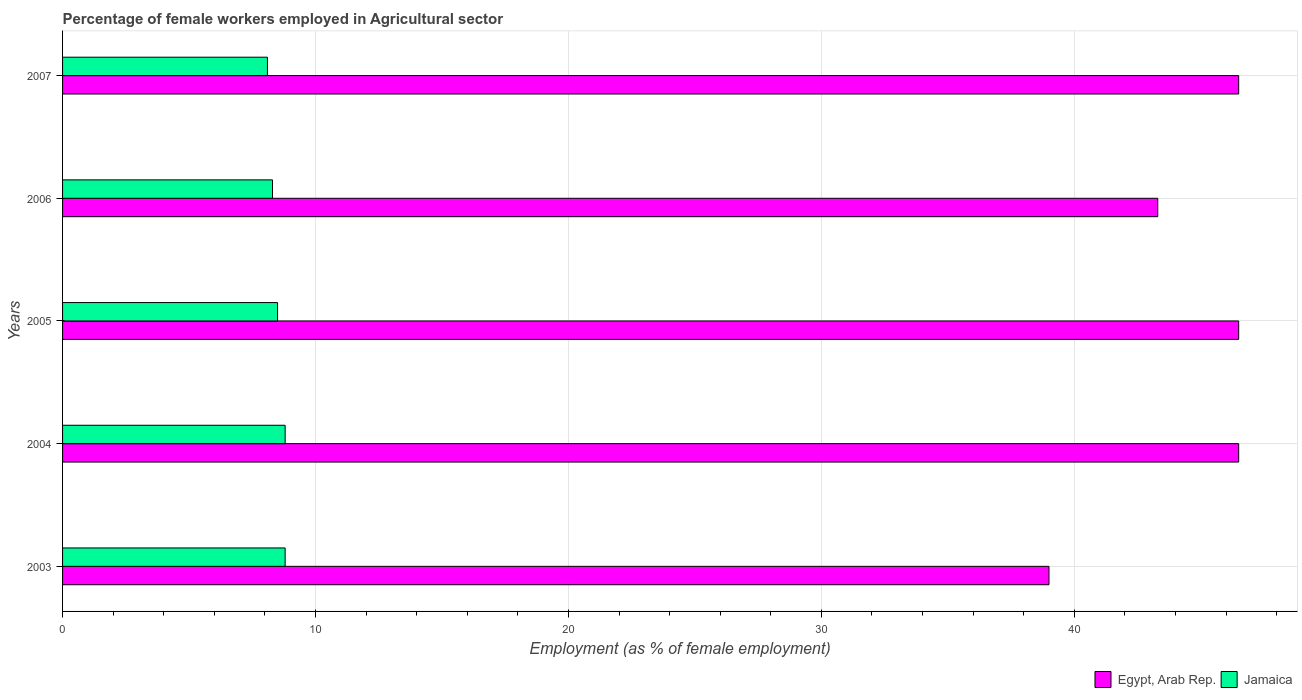How many groups of bars are there?
Ensure brevity in your answer.  5. Are the number of bars per tick equal to the number of legend labels?
Your response must be concise. Yes. How many bars are there on the 3rd tick from the bottom?
Your response must be concise. 2. What is the label of the 4th group of bars from the top?
Your response must be concise. 2004. What is the percentage of females employed in Agricultural sector in Egypt, Arab Rep. in 2003?
Offer a very short reply. 39. Across all years, what is the maximum percentage of females employed in Agricultural sector in Egypt, Arab Rep.?
Offer a terse response. 46.5. What is the total percentage of females employed in Agricultural sector in Egypt, Arab Rep. in the graph?
Keep it short and to the point. 221.8. What is the difference between the percentage of females employed in Agricultural sector in Jamaica in 2004 and the percentage of females employed in Agricultural sector in Egypt, Arab Rep. in 2005?
Offer a very short reply. -37.7. What is the average percentage of females employed in Agricultural sector in Jamaica per year?
Your answer should be compact. 8.5. In the year 2003, what is the difference between the percentage of females employed in Agricultural sector in Jamaica and percentage of females employed in Agricultural sector in Egypt, Arab Rep.?
Provide a succinct answer. -30.2. In how many years, is the percentage of females employed in Agricultural sector in Jamaica greater than 14 %?
Provide a succinct answer. 0. What is the ratio of the percentage of females employed in Agricultural sector in Egypt, Arab Rep. in 2003 to that in 2005?
Your answer should be compact. 0.84. Is the percentage of females employed in Agricultural sector in Egypt, Arab Rep. in 2004 less than that in 2006?
Your answer should be compact. No. Is the difference between the percentage of females employed in Agricultural sector in Jamaica in 2004 and 2007 greater than the difference between the percentage of females employed in Agricultural sector in Egypt, Arab Rep. in 2004 and 2007?
Make the answer very short. Yes. What is the difference between the highest and the lowest percentage of females employed in Agricultural sector in Egypt, Arab Rep.?
Provide a short and direct response. 7.5. In how many years, is the percentage of females employed in Agricultural sector in Egypt, Arab Rep. greater than the average percentage of females employed in Agricultural sector in Egypt, Arab Rep. taken over all years?
Offer a very short reply. 3. Is the sum of the percentage of females employed in Agricultural sector in Jamaica in 2005 and 2006 greater than the maximum percentage of females employed in Agricultural sector in Egypt, Arab Rep. across all years?
Your answer should be compact. No. What does the 2nd bar from the top in 2003 represents?
Offer a very short reply. Egypt, Arab Rep. What does the 1st bar from the bottom in 2005 represents?
Give a very brief answer. Egypt, Arab Rep. How many bars are there?
Keep it short and to the point. 10. Are all the bars in the graph horizontal?
Keep it short and to the point. Yes. Are the values on the major ticks of X-axis written in scientific E-notation?
Your answer should be compact. No. Where does the legend appear in the graph?
Your answer should be compact. Bottom right. How many legend labels are there?
Ensure brevity in your answer.  2. What is the title of the graph?
Your response must be concise. Percentage of female workers employed in Agricultural sector. What is the label or title of the X-axis?
Offer a very short reply. Employment (as % of female employment). What is the Employment (as % of female employment) in Jamaica in 2003?
Offer a very short reply. 8.8. What is the Employment (as % of female employment) of Egypt, Arab Rep. in 2004?
Your answer should be very brief. 46.5. What is the Employment (as % of female employment) of Jamaica in 2004?
Provide a short and direct response. 8.8. What is the Employment (as % of female employment) of Egypt, Arab Rep. in 2005?
Your answer should be very brief. 46.5. What is the Employment (as % of female employment) in Egypt, Arab Rep. in 2006?
Your answer should be very brief. 43.3. What is the Employment (as % of female employment) of Jamaica in 2006?
Keep it short and to the point. 8.3. What is the Employment (as % of female employment) of Egypt, Arab Rep. in 2007?
Give a very brief answer. 46.5. What is the Employment (as % of female employment) in Jamaica in 2007?
Make the answer very short. 8.1. Across all years, what is the maximum Employment (as % of female employment) in Egypt, Arab Rep.?
Offer a terse response. 46.5. Across all years, what is the maximum Employment (as % of female employment) in Jamaica?
Keep it short and to the point. 8.8. Across all years, what is the minimum Employment (as % of female employment) in Egypt, Arab Rep.?
Offer a terse response. 39. Across all years, what is the minimum Employment (as % of female employment) of Jamaica?
Your response must be concise. 8.1. What is the total Employment (as % of female employment) of Egypt, Arab Rep. in the graph?
Make the answer very short. 221.8. What is the total Employment (as % of female employment) in Jamaica in the graph?
Offer a terse response. 42.5. What is the difference between the Employment (as % of female employment) of Egypt, Arab Rep. in 2003 and that in 2004?
Provide a succinct answer. -7.5. What is the difference between the Employment (as % of female employment) of Jamaica in 2003 and that in 2005?
Your answer should be compact. 0.3. What is the difference between the Employment (as % of female employment) of Jamaica in 2003 and that in 2006?
Make the answer very short. 0.5. What is the difference between the Employment (as % of female employment) in Jamaica in 2003 and that in 2007?
Provide a succinct answer. 0.7. What is the difference between the Employment (as % of female employment) in Egypt, Arab Rep. in 2004 and that in 2005?
Keep it short and to the point. 0. What is the difference between the Employment (as % of female employment) in Egypt, Arab Rep. in 2005 and that in 2006?
Keep it short and to the point. 3.2. What is the difference between the Employment (as % of female employment) of Jamaica in 2006 and that in 2007?
Provide a succinct answer. 0.2. What is the difference between the Employment (as % of female employment) of Egypt, Arab Rep. in 2003 and the Employment (as % of female employment) of Jamaica in 2004?
Give a very brief answer. 30.2. What is the difference between the Employment (as % of female employment) in Egypt, Arab Rep. in 2003 and the Employment (as % of female employment) in Jamaica in 2005?
Your response must be concise. 30.5. What is the difference between the Employment (as % of female employment) of Egypt, Arab Rep. in 2003 and the Employment (as % of female employment) of Jamaica in 2006?
Make the answer very short. 30.7. What is the difference between the Employment (as % of female employment) in Egypt, Arab Rep. in 2003 and the Employment (as % of female employment) in Jamaica in 2007?
Provide a succinct answer. 30.9. What is the difference between the Employment (as % of female employment) in Egypt, Arab Rep. in 2004 and the Employment (as % of female employment) in Jamaica in 2005?
Your response must be concise. 38. What is the difference between the Employment (as % of female employment) in Egypt, Arab Rep. in 2004 and the Employment (as % of female employment) in Jamaica in 2006?
Offer a very short reply. 38.2. What is the difference between the Employment (as % of female employment) in Egypt, Arab Rep. in 2004 and the Employment (as % of female employment) in Jamaica in 2007?
Offer a very short reply. 38.4. What is the difference between the Employment (as % of female employment) in Egypt, Arab Rep. in 2005 and the Employment (as % of female employment) in Jamaica in 2006?
Provide a succinct answer. 38.2. What is the difference between the Employment (as % of female employment) of Egypt, Arab Rep. in 2005 and the Employment (as % of female employment) of Jamaica in 2007?
Your answer should be very brief. 38.4. What is the difference between the Employment (as % of female employment) of Egypt, Arab Rep. in 2006 and the Employment (as % of female employment) of Jamaica in 2007?
Your answer should be very brief. 35.2. What is the average Employment (as % of female employment) of Egypt, Arab Rep. per year?
Provide a short and direct response. 44.36. In the year 2003, what is the difference between the Employment (as % of female employment) of Egypt, Arab Rep. and Employment (as % of female employment) of Jamaica?
Offer a terse response. 30.2. In the year 2004, what is the difference between the Employment (as % of female employment) in Egypt, Arab Rep. and Employment (as % of female employment) in Jamaica?
Keep it short and to the point. 37.7. In the year 2006, what is the difference between the Employment (as % of female employment) of Egypt, Arab Rep. and Employment (as % of female employment) of Jamaica?
Keep it short and to the point. 35. In the year 2007, what is the difference between the Employment (as % of female employment) of Egypt, Arab Rep. and Employment (as % of female employment) of Jamaica?
Provide a short and direct response. 38.4. What is the ratio of the Employment (as % of female employment) in Egypt, Arab Rep. in 2003 to that in 2004?
Provide a short and direct response. 0.84. What is the ratio of the Employment (as % of female employment) in Egypt, Arab Rep. in 2003 to that in 2005?
Your answer should be compact. 0.84. What is the ratio of the Employment (as % of female employment) in Jamaica in 2003 to that in 2005?
Offer a terse response. 1.04. What is the ratio of the Employment (as % of female employment) in Egypt, Arab Rep. in 2003 to that in 2006?
Provide a short and direct response. 0.9. What is the ratio of the Employment (as % of female employment) in Jamaica in 2003 to that in 2006?
Give a very brief answer. 1.06. What is the ratio of the Employment (as % of female employment) of Egypt, Arab Rep. in 2003 to that in 2007?
Your answer should be compact. 0.84. What is the ratio of the Employment (as % of female employment) of Jamaica in 2003 to that in 2007?
Make the answer very short. 1.09. What is the ratio of the Employment (as % of female employment) of Jamaica in 2004 to that in 2005?
Provide a short and direct response. 1.04. What is the ratio of the Employment (as % of female employment) of Egypt, Arab Rep. in 2004 to that in 2006?
Provide a succinct answer. 1.07. What is the ratio of the Employment (as % of female employment) of Jamaica in 2004 to that in 2006?
Your answer should be compact. 1.06. What is the ratio of the Employment (as % of female employment) of Jamaica in 2004 to that in 2007?
Ensure brevity in your answer.  1.09. What is the ratio of the Employment (as % of female employment) in Egypt, Arab Rep. in 2005 to that in 2006?
Offer a very short reply. 1.07. What is the ratio of the Employment (as % of female employment) in Jamaica in 2005 to that in 2006?
Your response must be concise. 1.02. What is the ratio of the Employment (as % of female employment) in Jamaica in 2005 to that in 2007?
Offer a very short reply. 1.05. What is the ratio of the Employment (as % of female employment) in Egypt, Arab Rep. in 2006 to that in 2007?
Your answer should be compact. 0.93. What is the ratio of the Employment (as % of female employment) of Jamaica in 2006 to that in 2007?
Make the answer very short. 1.02. What is the difference between the highest and the second highest Employment (as % of female employment) of Jamaica?
Your answer should be compact. 0. 